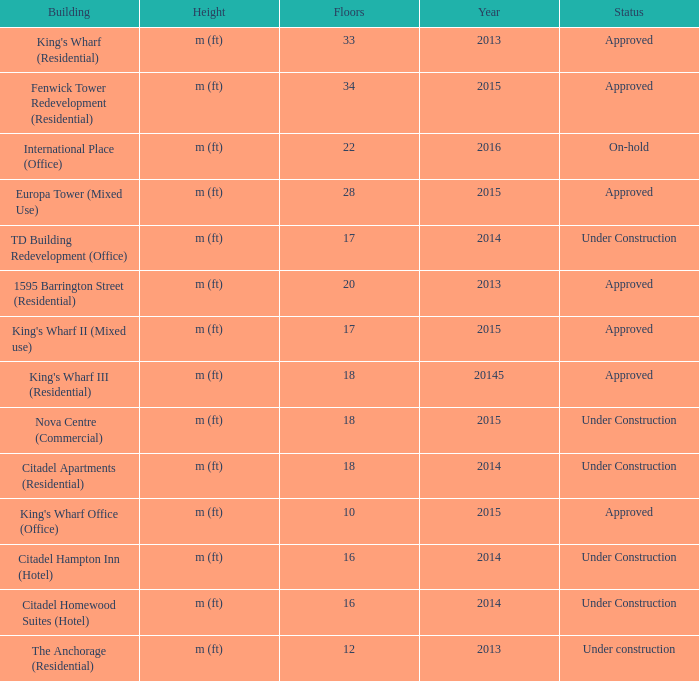What are the number of floors for the building of td building redevelopment (office)? 17.0. 